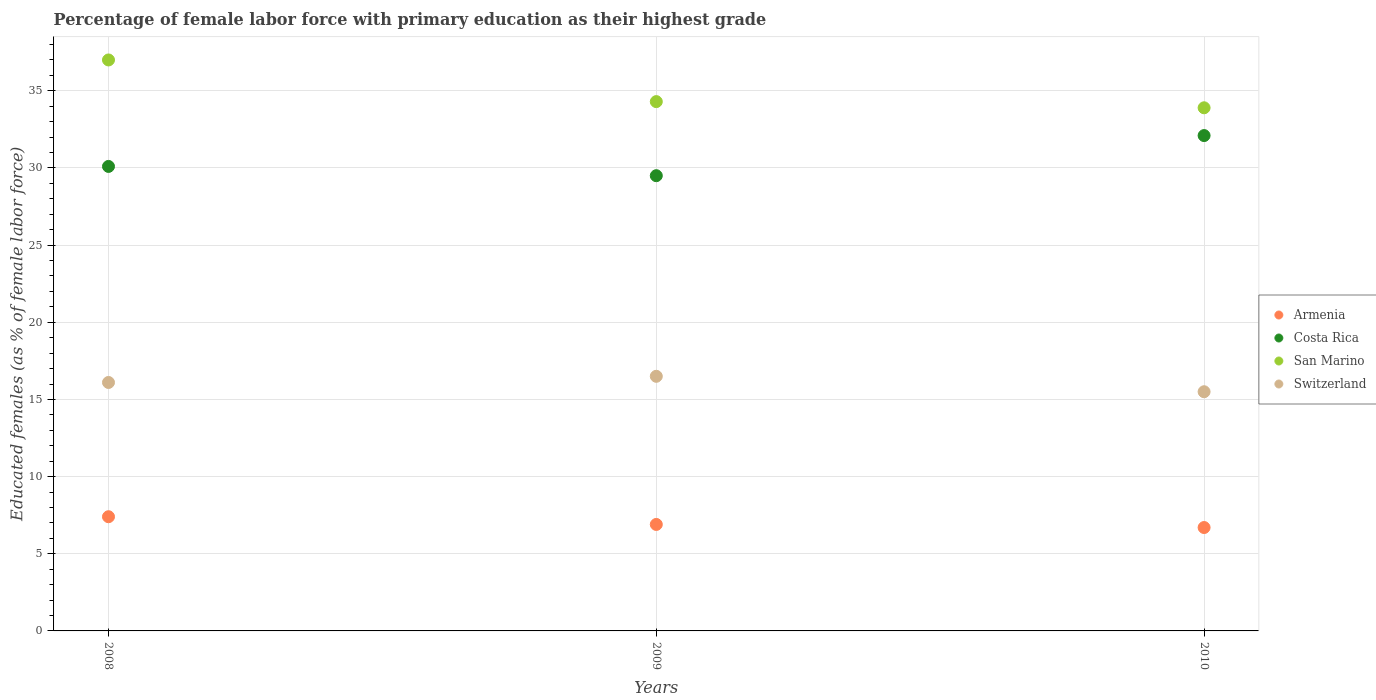How many different coloured dotlines are there?
Give a very brief answer. 4. What is the percentage of female labor force with primary education in Costa Rica in 2010?
Give a very brief answer. 32.1. Across all years, what is the maximum percentage of female labor force with primary education in Armenia?
Offer a terse response. 7.4. Across all years, what is the minimum percentage of female labor force with primary education in Costa Rica?
Your answer should be compact. 29.5. What is the total percentage of female labor force with primary education in Armenia in the graph?
Your answer should be very brief. 21. What is the difference between the percentage of female labor force with primary education in Switzerland in 2008 and that in 2010?
Your answer should be compact. 0.6. What is the difference between the percentage of female labor force with primary education in Armenia in 2010 and the percentage of female labor force with primary education in San Marino in 2009?
Provide a succinct answer. -27.6. What is the average percentage of female labor force with primary education in San Marino per year?
Ensure brevity in your answer.  35.07. In the year 2010, what is the difference between the percentage of female labor force with primary education in San Marino and percentage of female labor force with primary education in Switzerland?
Offer a terse response. 18.4. What is the ratio of the percentage of female labor force with primary education in Costa Rica in 2009 to that in 2010?
Give a very brief answer. 0.92. What is the difference between the highest and the lowest percentage of female labor force with primary education in Armenia?
Offer a very short reply. 0.7. In how many years, is the percentage of female labor force with primary education in Switzerland greater than the average percentage of female labor force with primary education in Switzerland taken over all years?
Make the answer very short. 2. Is the sum of the percentage of female labor force with primary education in Switzerland in 2008 and 2009 greater than the maximum percentage of female labor force with primary education in Costa Rica across all years?
Your answer should be very brief. Yes. Is it the case that in every year, the sum of the percentage of female labor force with primary education in Costa Rica and percentage of female labor force with primary education in San Marino  is greater than the sum of percentage of female labor force with primary education in Switzerland and percentage of female labor force with primary education in Armenia?
Give a very brief answer. Yes. Is it the case that in every year, the sum of the percentage of female labor force with primary education in Costa Rica and percentage of female labor force with primary education in Armenia  is greater than the percentage of female labor force with primary education in Switzerland?
Provide a short and direct response. Yes. How many dotlines are there?
Provide a short and direct response. 4. Are the values on the major ticks of Y-axis written in scientific E-notation?
Provide a succinct answer. No. Does the graph contain grids?
Provide a succinct answer. Yes. Where does the legend appear in the graph?
Your answer should be very brief. Center right. How are the legend labels stacked?
Your answer should be compact. Vertical. What is the title of the graph?
Your answer should be very brief. Percentage of female labor force with primary education as their highest grade. What is the label or title of the Y-axis?
Provide a succinct answer. Educated females (as % of female labor force). What is the Educated females (as % of female labor force) in Armenia in 2008?
Give a very brief answer. 7.4. What is the Educated females (as % of female labor force) of Costa Rica in 2008?
Your answer should be very brief. 30.1. What is the Educated females (as % of female labor force) of San Marino in 2008?
Keep it short and to the point. 37. What is the Educated females (as % of female labor force) in Switzerland in 2008?
Provide a succinct answer. 16.1. What is the Educated females (as % of female labor force) of Armenia in 2009?
Make the answer very short. 6.9. What is the Educated females (as % of female labor force) of Costa Rica in 2009?
Offer a very short reply. 29.5. What is the Educated females (as % of female labor force) in San Marino in 2009?
Offer a terse response. 34.3. What is the Educated females (as % of female labor force) of Armenia in 2010?
Make the answer very short. 6.7. What is the Educated females (as % of female labor force) in Costa Rica in 2010?
Ensure brevity in your answer.  32.1. What is the Educated females (as % of female labor force) of San Marino in 2010?
Provide a succinct answer. 33.9. What is the Educated females (as % of female labor force) in Switzerland in 2010?
Provide a succinct answer. 15.5. Across all years, what is the maximum Educated females (as % of female labor force) in Armenia?
Your answer should be very brief. 7.4. Across all years, what is the maximum Educated females (as % of female labor force) of Costa Rica?
Your answer should be compact. 32.1. Across all years, what is the minimum Educated females (as % of female labor force) of Armenia?
Your response must be concise. 6.7. Across all years, what is the minimum Educated females (as % of female labor force) of Costa Rica?
Your answer should be very brief. 29.5. Across all years, what is the minimum Educated females (as % of female labor force) of San Marino?
Offer a terse response. 33.9. Across all years, what is the minimum Educated females (as % of female labor force) of Switzerland?
Give a very brief answer. 15.5. What is the total Educated females (as % of female labor force) of Armenia in the graph?
Provide a succinct answer. 21. What is the total Educated females (as % of female labor force) in Costa Rica in the graph?
Your response must be concise. 91.7. What is the total Educated females (as % of female labor force) of San Marino in the graph?
Provide a succinct answer. 105.2. What is the total Educated females (as % of female labor force) of Switzerland in the graph?
Make the answer very short. 48.1. What is the difference between the Educated females (as % of female labor force) of Costa Rica in 2008 and that in 2009?
Make the answer very short. 0.6. What is the difference between the Educated females (as % of female labor force) in San Marino in 2008 and that in 2010?
Give a very brief answer. 3.1. What is the difference between the Educated females (as % of female labor force) in Switzerland in 2008 and that in 2010?
Keep it short and to the point. 0.6. What is the difference between the Educated females (as % of female labor force) of Switzerland in 2009 and that in 2010?
Ensure brevity in your answer.  1. What is the difference between the Educated females (as % of female labor force) of Armenia in 2008 and the Educated females (as % of female labor force) of Costa Rica in 2009?
Offer a very short reply. -22.1. What is the difference between the Educated females (as % of female labor force) in Armenia in 2008 and the Educated females (as % of female labor force) in San Marino in 2009?
Ensure brevity in your answer.  -26.9. What is the difference between the Educated females (as % of female labor force) of Armenia in 2008 and the Educated females (as % of female labor force) of Switzerland in 2009?
Your answer should be very brief. -9.1. What is the difference between the Educated females (as % of female labor force) in Costa Rica in 2008 and the Educated females (as % of female labor force) in San Marino in 2009?
Offer a terse response. -4.2. What is the difference between the Educated females (as % of female labor force) in San Marino in 2008 and the Educated females (as % of female labor force) in Switzerland in 2009?
Provide a short and direct response. 20.5. What is the difference between the Educated females (as % of female labor force) in Armenia in 2008 and the Educated females (as % of female labor force) in Costa Rica in 2010?
Keep it short and to the point. -24.7. What is the difference between the Educated females (as % of female labor force) of Armenia in 2008 and the Educated females (as % of female labor force) of San Marino in 2010?
Provide a short and direct response. -26.5. What is the difference between the Educated females (as % of female labor force) in Armenia in 2008 and the Educated females (as % of female labor force) in Switzerland in 2010?
Your answer should be compact. -8.1. What is the difference between the Educated females (as % of female labor force) of Costa Rica in 2008 and the Educated females (as % of female labor force) of San Marino in 2010?
Your response must be concise. -3.8. What is the difference between the Educated females (as % of female labor force) in Costa Rica in 2008 and the Educated females (as % of female labor force) in Switzerland in 2010?
Make the answer very short. 14.6. What is the difference between the Educated females (as % of female labor force) of Armenia in 2009 and the Educated females (as % of female labor force) of Costa Rica in 2010?
Provide a short and direct response. -25.2. What is the difference between the Educated females (as % of female labor force) of Armenia in 2009 and the Educated females (as % of female labor force) of San Marino in 2010?
Give a very brief answer. -27. What is the difference between the Educated females (as % of female labor force) of Armenia in 2009 and the Educated females (as % of female labor force) of Switzerland in 2010?
Ensure brevity in your answer.  -8.6. What is the difference between the Educated females (as % of female labor force) of Costa Rica in 2009 and the Educated females (as % of female labor force) of San Marino in 2010?
Your response must be concise. -4.4. What is the difference between the Educated females (as % of female labor force) in San Marino in 2009 and the Educated females (as % of female labor force) in Switzerland in 2010?
Give a very brief answer. 18.8. What is the average Educated females (as % of female labor force) of Armenia per year?
Give a very brief answer. 7. What is the average Educated females (as % of female labor force) of Costa Rica per year?
Keep it short and to the point. 30.57. What is the average Educated females (as % of female labor force) in San Marino per year?
Your answer should be compact. 35.07. What is the average Educated females (as % of female labor force) in Switzerland per year?
Provide a succinct answer. 16.03. In the year 2008, what is the difference between the Educated females (as % of female labor force) of Armenia and Educated females (as % of female labor force) of Costa Rica?
Make the answer very short. -22.7. In the year 2008, what is the difference between the Educated females (as % of female labor force) of Armenia and Educated females (as % of female labor force) of San Marino?
Make the answer very short. -29.6. In the year 2008, what is the difference between the Educated females (as % of female labor force) of San Marino and Educated females (as % of female labor force) of Switzerland?
Offer a very short reply. 20.9. In the year 2009, what is the difference between the Educated females (as % of female labor force) in Armenia and Educated females (as % of female labor force) in Costa Rica?
Ensure brevity in your answer.  -22.6. In the year 2009, what is the difference between the Educated females (as % of female labor force) in Armenia and Educated females (as % of female labor force) in San Marino?
Your answer should be compact. -27.4. In the year 2009, what is the difference between the Educated females (as % of female labor force) in Armenia and Educated females (as % of female labor force) in Switzerland?
Your answer should be very brief. -9.6. In the year 2009, what is the difference between the Educated females (as % of female labor force) in Costa Rica and Educated females (as % of female labor force) in Switzerland?
Your response must be concise. 13. In the year 2009, what is the difference between the Educated females (as % of female labor force) of San Marino and Educated females (as % of female labor force) of Switzerland?
Your answer should be very brief. 17.8. In the year 2010, what is the difference between the Educated females (as % of female labor force) of Armenia and Educated females (as % of female labor force) of Costa Rica?
Your answer should be compact. -25.4. In the year 2010, what is the difference between the Educated females (as % of female labor force) of Armenia and Educated females (as % of female labor force) of San Marino?
Your answer should be compact. -27.2. In the year 2010, what is the difference between the Educated females (as % of female labor force) of Costa Rica and Educated females (as % of female labor force) of San Marino?
Your response must be concise. -1.8. In the year 2010, what is the difference between the Educated females (as % of female labor force) in Costa Rica and Educated females (as % of female labor force) in Switzerland?
Your answer should be very brief. 16.6. What is the ratio of the Educated females (as % of female labor force) in Armenia in 2008 to that in 2009?
Offer a very short reply. 1.07. What is the ratio of the Educated females (as % of female labor force) in Costa Rica in 2008 to that in 2009?
Your answer should be very brief. 1.02. What is the ratio of the Educated females (as % of female labor force) in San Marino in 2008 to that in 2009?
Give a very brief answer. 1.08. What is the ratio of the Educated females (as % of female labor force) of Switzerland in 2008 to that in 2009?
Give a very brief answer. 0.98. What is the ratio of the Educated females (as % of female labor force) of Armenia in 2008 to that in 2010?
Your response must be concise. 1.1. What is the ratio of the Educated females (as % of female labor force) in Costa Rica in 2008 to that in 2010?
Offer a terse response. 0.94. What is the ratio of the Educated females (as % of female labor force) of San Marino in 2008 to that in 2010?
Your response must be concise. 1.09. What is the ratio of the Educated females (as % of female labor force) of Switzerland in 2008 to that in 2010?
Your response must be concise. 1.04. What is the ratio of the Educated females (as % of female labor force) in Armenia in 2009 to that in 2010?
Your answer should be very brief. 1.03. What is the ratio of the Educated females (as % of female labor force) of Costa Rica in 2009 to that in 2010?
Your response must be concise. 0.92. What is the ratio of the Educated females (as % of female labor force) in San Marino in 2009 to that in 2010?
Offer a terse response. 1.01. What is the ratio of the Educated females (as % of female labor force) in Switzerland in 2009 to that in 2010?
Make the answer very short. 1.06. What is the difference between the highest and the second highest Educated females (as % of female labor force) in Costa Rica?
Make the answer very short. 2. What is the difference between the highest and the second highest Educated females (as % of female labor force) of San Marino?
Make the answer very short. 2.7. What is the difference between the highest and the second highest Educated females (as % of female labor force) in Switzerland?
Make the answer very short. 0.4. What is the difference between the highest and the lowest Educated females (as % of female labor force) of Armenia?
Your answer should be compact. 0.7. What is the difference between the highest and the lowest Educated females (as % of female labor force) in San Marino?
Make the answer very short. 3.1. What is the difference between the highest and the lowest Educated females (as % of female labor force) in Switzerland?
Give a very brief answer. 1. 